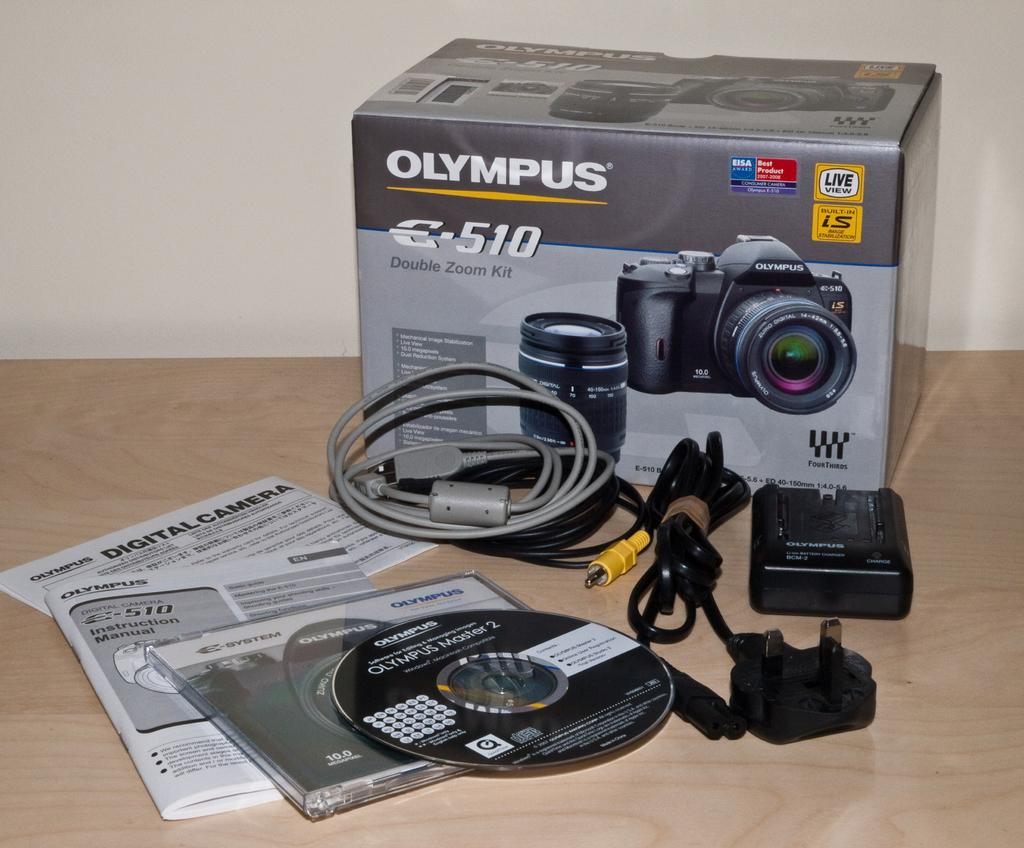What is the main object in the image? There is a camera in the image. What can be seen on the table in the image? There are other objects on the table in the image. What type of skirt is being worn by the camera in the image? There is no skirt present in the image, as the main subject is a camera. 